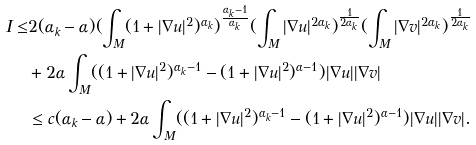<formula> <loc_0><loc_0><loc_500><loc_500>I \leq & 2 ( \alpha _ { k } - \alpha ) ( \int _ { M } ( 1 + | \nabla u | ^ { 2 } ) ^ { \alpha _ { k } } ) ^ { \frac { \alpha _ { k } - 1 } { \alpha _ { k } } } ( \int _ { M } | \nabla u | ^ { 2 \alpha _ { k } } ) ^ { \frac { 1 } { 2 \alpha _ { k } } } ( \int _ { M } | \nabla v | ^ { 2 \alpha _ { k } } ) ^ { \frac { 1 } { 2 \alpha _ { k } } } \\ & + 2 \alpha \int _ { M } ( ( 1 + | \nabla u | ^ { 2 } ) ^ { \alpha _ { k } - 1 } - ( 1 + | \nabla u | ^ { 2 } ) ^ { \alpha - 1 } ) | \nabla u | | \nabla v | \\ & \leq c ( \alpha _ { k } - \alpha ) + 2 \alpha \int _ { M } ( ( 1 + | \nabla u | ^ { 2 } ) ^ { \alpha _ { k } - 1 } - ( 1 + | \nabla u | ^ { 2 } ) ^ { \alpha - 1 } ) | \nabla u | | \nabla v | .</formula> 